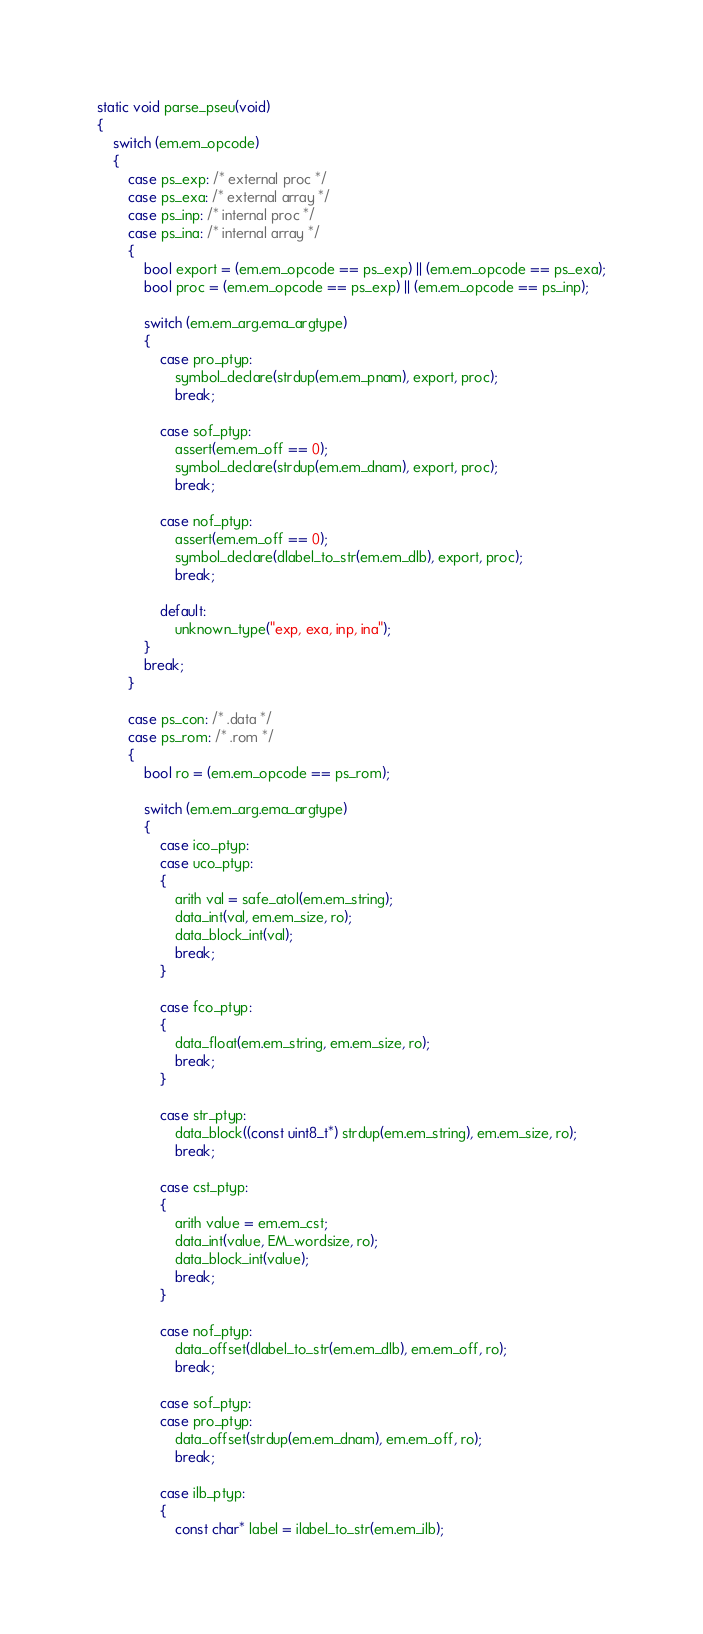Convert code to text. <code><loc_0><loc_0><loc_500><loc_500><_C_>
static void parse_pseu(void)
{
	switch (em.em_opcode)
	{
		case ps_exp: /* external proc */
		case ps_exa: /* external array */
		case ps_inp: /* internal proc */
		case ps_ina: /* internal array */
		{
			bool export = (em.em_opcode == ps_exp) || (em.em_opcode == ps_exa);
			bool proc = (em.em_opcode == ps_exp) || (em.em_opcode == ps_inp);

			switch (em.em_arg.ema_argtype)
			{
				case pro_ptyp:
					symbol_declare(strdup(em.em_pnam), export, proc);
					break;

				case sof_ptyp:
                    assert(em.em_off == 0);
					symbol_declare(strdup(em.em_dnam), export, proc);
					break;

                case nof_ptyp:
                    assert(em.em_off == 0);
                    symbol_declare(dlabel_to_str(em.em_dlb), export, proc);
                    break;

				default:
                    unknown_type("exp, exa, inp, ina");
			}
			break;
		}

		case ps_con: /* .data */
		case ps_rom: /* .rom */
        {
            bool ro = (em.em_opcode == ps_rom);

			switch (em.em_arg.ema_argtype)
			{
				case ico_ptyp:
				case uco_ptyp:
                {
                    arith val = safe_atol(em.em_string);
                    data_int(val, em.em_size, ro);
                    data_block_int(val);
                    break;
                }

                case fco_ptyp:
                {
                    data_float(em.em_string, em.em_size, ro);
                    break;
                }

				case str_ptyp:
                    data_block((const uint8_t*) strdup(em.em_string), em.em_size, ro);
					break;

                case cst_ptyp:
                {
                    arith value = em.em_cst;
                    data_int(value, EM_wordsize, ro);
                    data_block_int(value);
                    break;
				}
                    
                case nof_ptyp:
                    data_offset(dlabel_to_str(em.em_dlb), em.em_off, ro);
                    break;

                case sof_ptyp:
                case pro_ptyp:
                    data_offset(strdup(em.em_dnam), em.em_off, ro);
                    break;

                case ilb_ptyp:
                {
                    const char* label = ilabel_to_str(em.em_ilb);</code> 